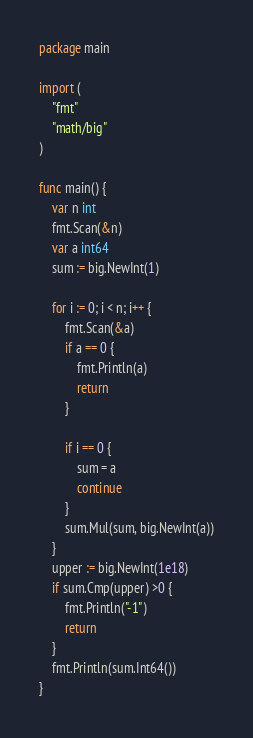Convert code to text. <code><loc_0><loc_0><loc_500><loc_500><_Go_>package main

import (
	"fmt"
	"math/big"
)

func main() {
	var n int
	fmt.Scan(&n)
	var a int64
	sum := big.NewInt(1)

	for i := 0; i < n; i++ {
		fmt.Scan(&a)
		if a == 0 {
			fmt.Println(a)
			return
		}

		if i == 0 {
			sum = a
			continue
		}
		sum.Mul(sum, big.NewInt(a))
	}
	upper := big.NewInt(1e18)
	if sum.Cmp(upper) >0 {
		fmt.Println("-1")
		return
	}
	fmt.Println(sum.Int64())
}
</code> 